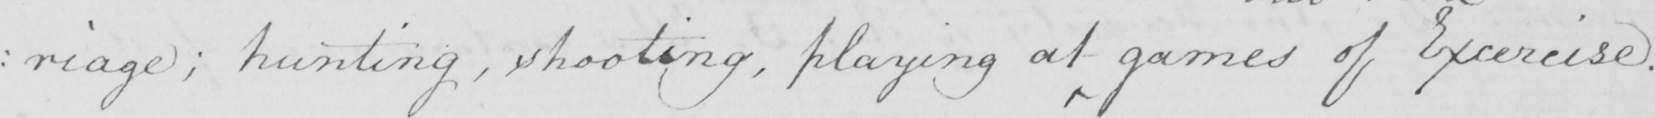What is written in this line of handwriting? : riage ; hunting , shooting , playing at games of Exercise . 